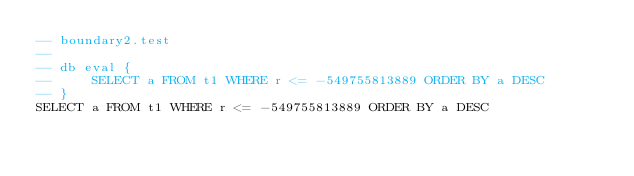Convert code to text. <code><loc_0><loc_0><loc_500><loc_500><_SQL_>-- boundary2.test
-- 
-- db eval {
--     SELECT a FROM t1 WHERE r <= -549755813889 ORDER BY a DESC
-- }
SELECT a FROM t1 WHERE r <= -549755813889 ORDER BY a DESC</code> 